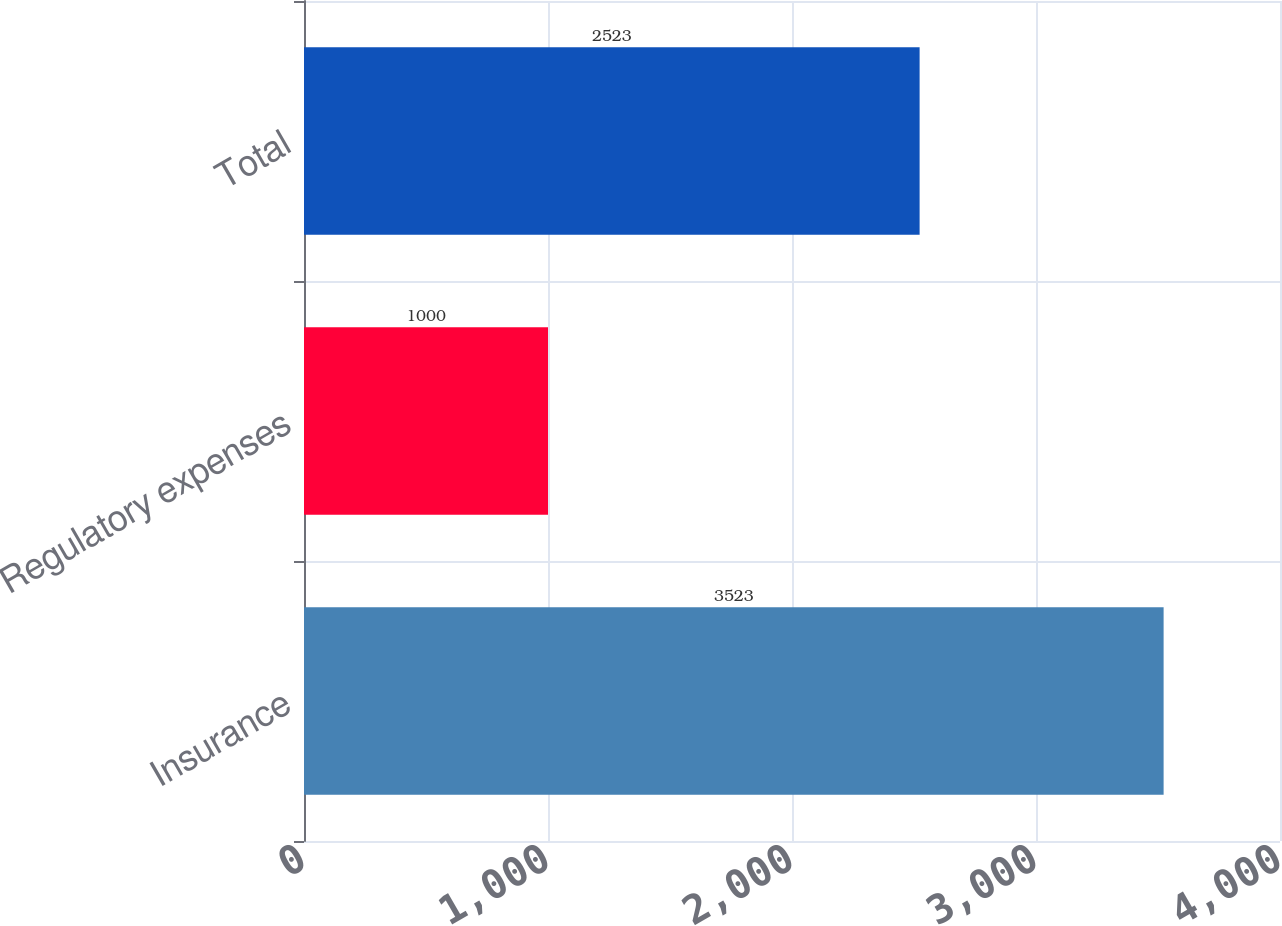Convert chart to OTSL. <chart><loc_0><loc_0><loc_500><loc_500><bar_chart><fcel>Insurance<fcel>Regulatory expenses<fcel>Total<nl><fcel>3523<fcel>1000<fcel>2523<nl></chart> 